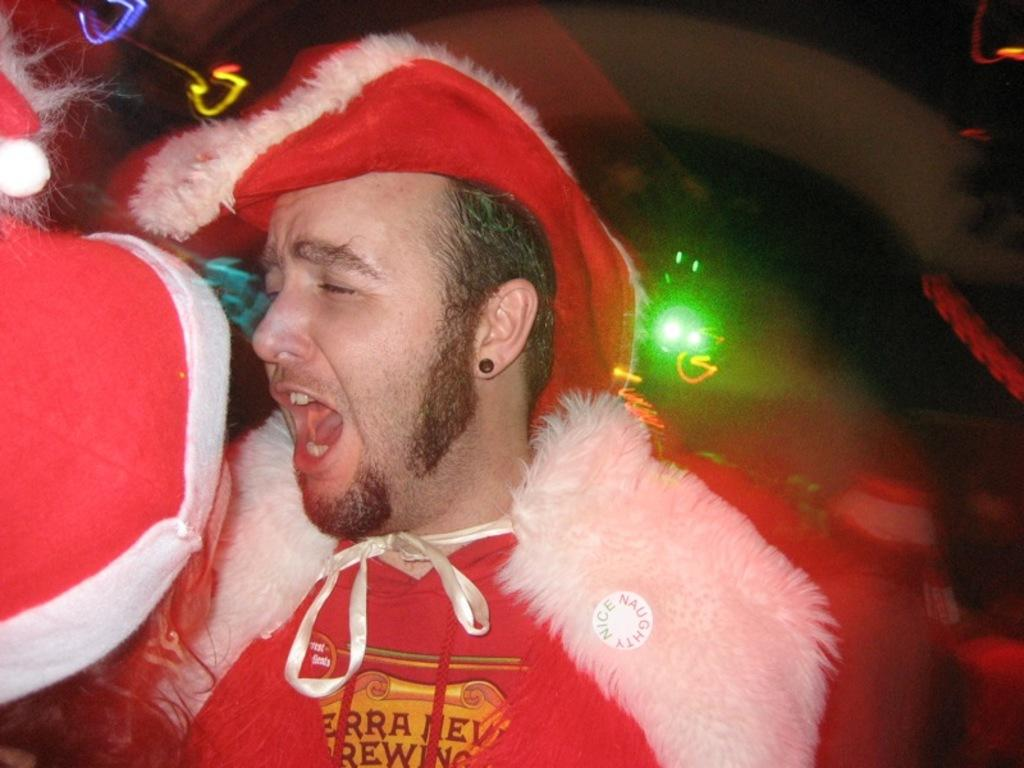What is the main subject of the image? There is a man in the image. What is the man wearing in the image? The man is wearing a costume. Can you see a veil covering the man's face in the image? There is no veil present in the image; the man is wearing a costume. Is the man producing steam from his body in the image? There is no steam present in the image; the man is wearing a costume. 